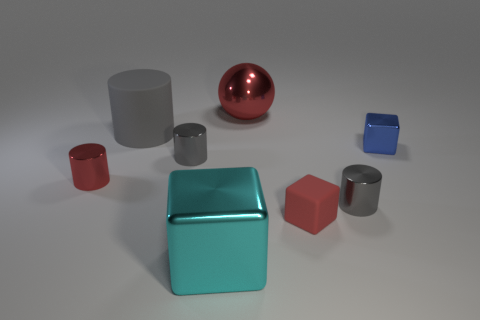Subtract all shiny cylinders. How many cylinders are left? 1 Add 2 large blue rubber cylinders. How many objects exist? 10 Subtract all yellow spheres. How many gray cylinders are left? 3 Subtract 3 cylinders. How many cylinders are left? 1 Subtract all gray cylinders. How many cylinders are left? 1 Subtract all shiny cubes. Subtract all small gray things. How many objects are left? 4 Add 5 large red balls. How many large red balls are left? 6 Add 1 blue metallic things. How many blue metallic things exist? 2 Subtract 0 brown blocks. How many objects are left? 8 Subtract all blocks. How many objects are left? 5 